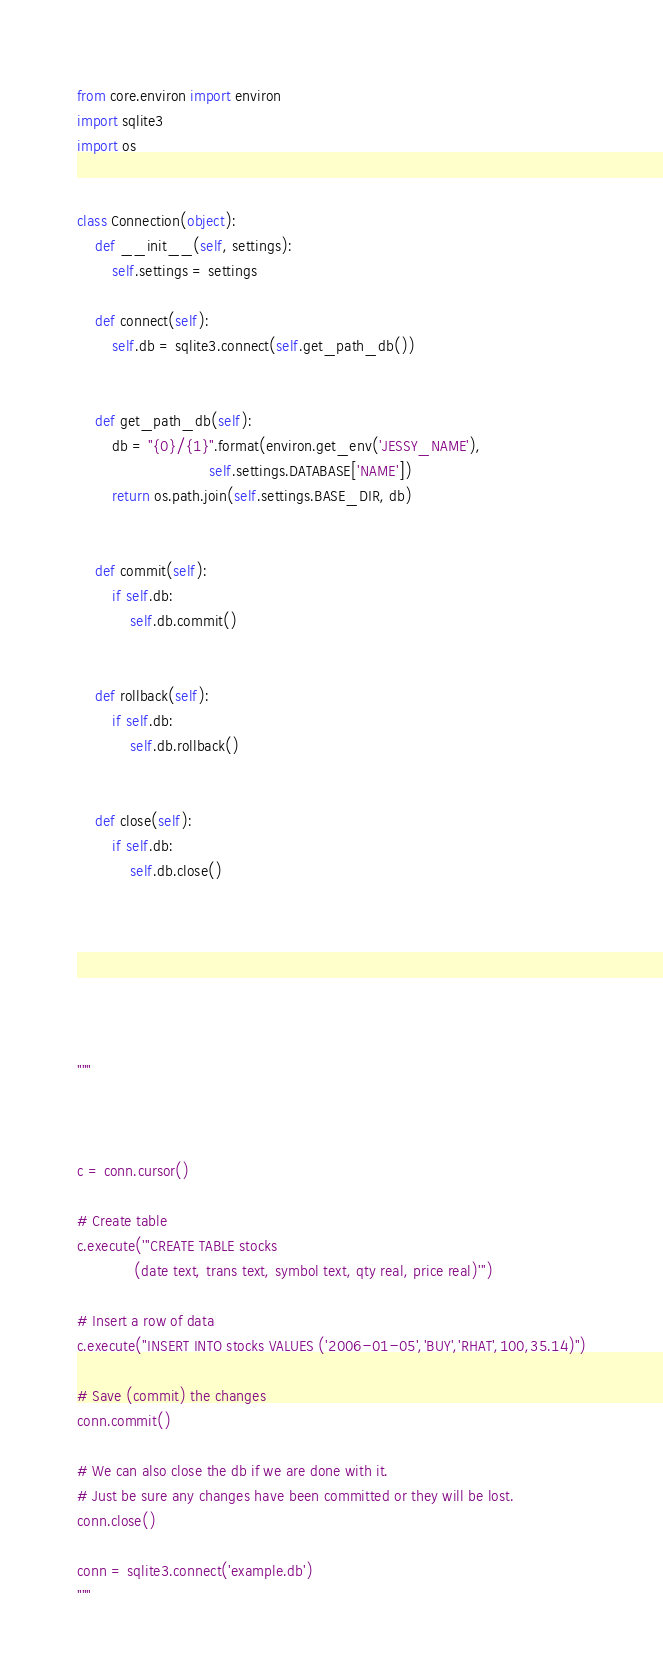<code> <loc_0><loc_0><loc_500><loc_500><_Python_>from core.environ import environ
import sqlite3
import os


class Connection(object):
    def __init__(self, settings):
        self.settings = settings

    def connect(self):
        self.db = sqlite3.connect(self.get_path_db())


    def get_path_db(self):
        db = "{0}/{1}".format(environ.get_env('JESSY_NAME'),
                              self.settings.DATABASE['NAME'])
        return os.path.join(self.settings.BASE_DIR, db)


    def commit(self):
        if self.db:
            self.db.commit()


    def rollback(self):
        if self.db:
            self.db.rollback()


    def close(self):
        if self.db:
            self.db.close()







"""



c = conn.cursor()

# Create table
c.execute('''CREATE TABLE stocks
             (date text, trans text, symbol text, qty real, price real)''')

# Insert a row of data
c.execute("INSERT INTO stocks VALUES ('2006-01-05','BUY','RHAT',100,35.14)")

# Save (commit) the changes
conn.commit()

# We can also close the db if we are done with it.
# Just be sure any changes have been committed or they will be lost.
conn.close()

conn = sqlite3.connect('example.db')
"""
</code> 